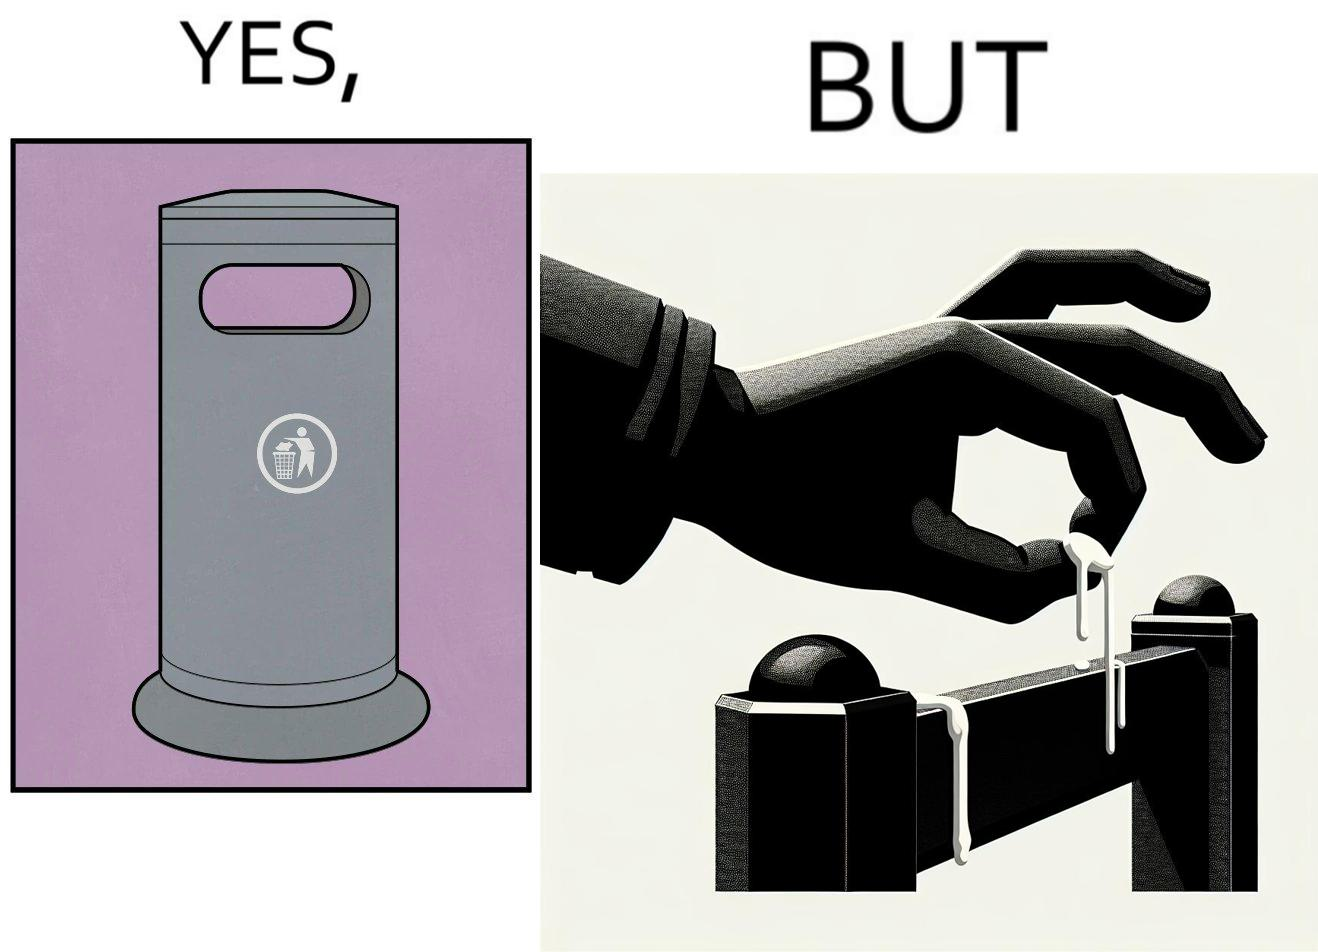Describe what you see in the left and right parts of this image. In the left part of the image: It is a garbage bin In the right part of the image: It is a human hand sticking chewing gum on public property 